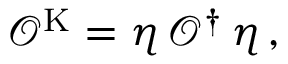Convert formula to latex. <formula><loc_0><loc_0><loc_500><loc_500>\mathcal { O } ^ { K } = \eta \, \mathcal { O } ^ { \dagger } \, \eta \, ,</formula> 